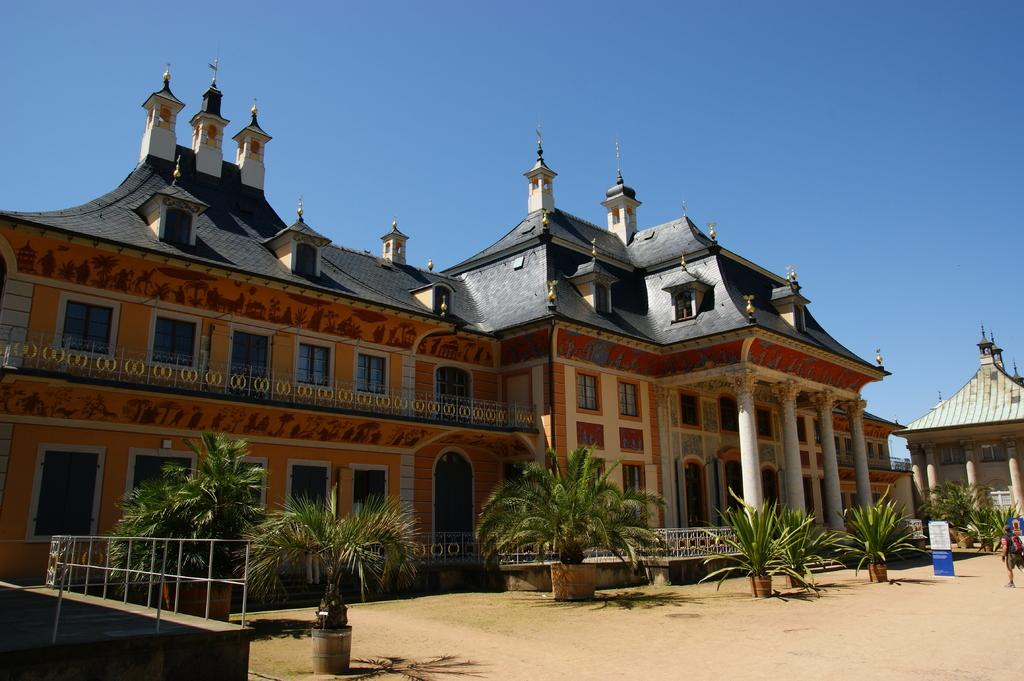What type of building is the main subject of the image? There is a palace in the image. What architectural feature can be observed on the palace? The palace has many windows. What type of vegetation is present in front of the palace? There are palm trees in front of the palace. What is visible above the palace in the image? The sky is visible above the palace. What type of behavior can be observed in the north side of the palace in the image? There is no information about the behavior or the north side of the palace in the image. 